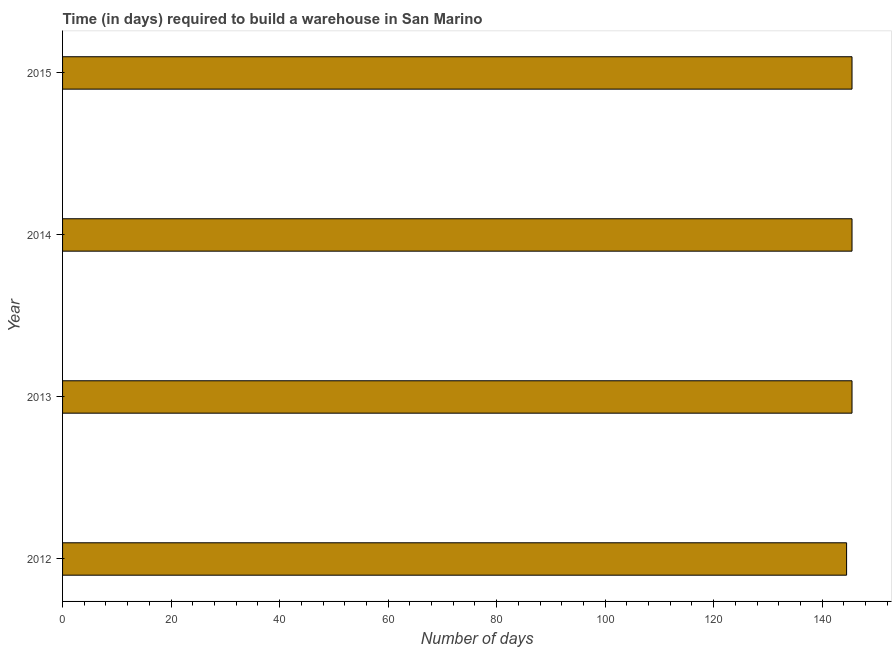Does the graph contain any zero values?
Keep it short and to the point. No. What is the title of the graph?
Keep it short and to the point. Time (in days) required to build a warehouse in San Marino. What is the label or title of the X-axis?
Your response must be concise. Number of days. What is the time required to build a warehouse in 2013?
Make the answer very short. 145.5. Across all years, what is the maximum time required to build a warehouse?
Ensure brevity in your answer.  145.5. Across all years, what is the minimum time required to build a warehouse?
Offer a terse response. 144.5. In which year was the time required to build a warehouse maximum?
Make the answer very short. 2013. In which year was the time required to build a warehouse minimum?
Make the answer very short. 2012. What is the sum of the time required to build a warehouse?
Ensure brevity in your answer.  581. What is the difference between the time required to build a warehouse in 2012 and 2015?
Make the answer very short. -1. What is the average time required to build a warehouse per year?
Make the answer very short. 145.25. What is the median time required to build a warehouse?
Keep it short and to the point. 145.5. In how many years, is the time required to build a warehouse greater than 140 days?
Make the answer very short. 4. What is the ratio of the time required to build a warehouse in 2012 to that in 2014?
Provide a succinct answer. 0.99. Is the difference between the time required to build a warehouse in 2013 and 2015 greater than the difference between any two years?
Your answer should be compact. No. What is the difference between the highest and the second highest time required to build a warehouse?
Your answer should be compact. 0. What is the difference between the highest and the lowest time required to build a warehouse?
Offer a terse response. 1. In how many years, is the time required to build a warehouse greater than the average time required to build a warehouse taken over all years?
Ensure brevity in your answer.  3. Are all the bars in the graph horizontal?
Provide a succinct answer. Yes. Are the values on the major ticks of X-axis written in scientific E-notation?
Your response must be concise. No. What is the Number of days in 2012?
Ensure brevity in your answer.  144.5. What is the Number of days in 2013?
Offer a very short reply. 145.5. What is the Number of days in 2014?
Make the answer very short. 145.5. What is the Number of days of 2015?
Your answer should be very brief. 145.5. What is the difference between the Number of days in 2012 and 2014?
Your answer should be compact. -1. What is the difference between the Number of days in 2013 and 2014?
Your answer should be very brief. 0. What is the difference between the Number of days in 2013 and 2015?
Your answer should be compact. 0. What is the difference between the Number of days in 2014 and 2015?
Give a very brief answer. 0. What is the ratio of the Number of days in 2012 to that in 2014?
Provide a short and direct response. 0.99. What is the ratio of the Number of days in 2012 to that in 2015?
Provide a short and direct response. 0.99. What is the ratio of the Number of days in 2013 to that in 2014?
Your response must be concise. 1. What is the ratio of the Number of days in 2014 to that in 2015?
Give a very brief answer. 1. 